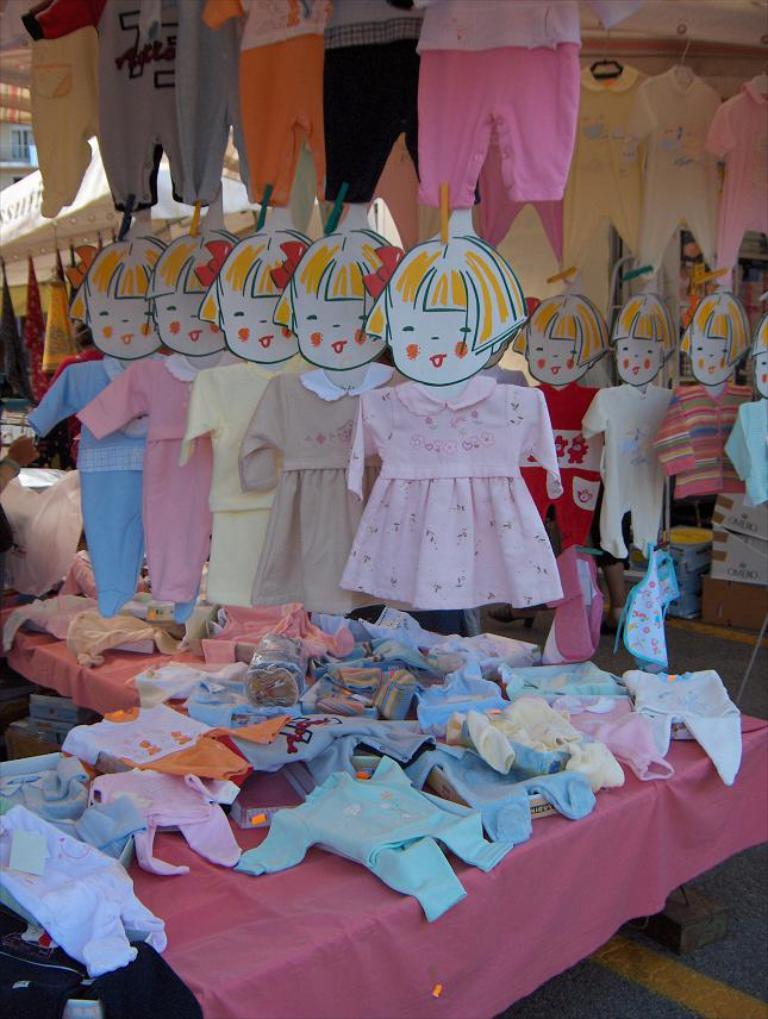What is located on the table in the foreground of the image? There are clothes on a table in the foreground of the image. Where else can clothes be seen in the image? Clothes are hanging from the ceiling on the right side of the image and at the top of the image. What is visible in the background of the image? There is a window visible in the background of the image. What type of structure does the window belong to? The window belongs to a building. Can you see the mom in the crowd in the image? There is no mom or crowd present in the image. What type of creature has fangs in the image? There are no creatures with fangs present in the image. 